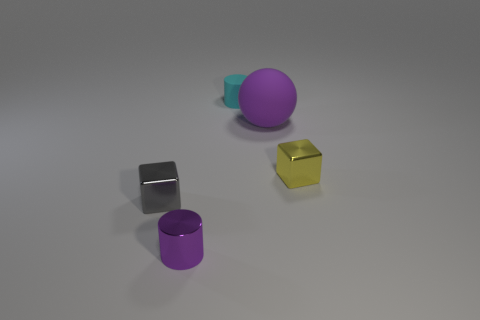There is a yellow thing that is the same shape as the gray metal thing; what is its size?
Your answer should be compact. Small. The small rubber thing that is the same shape as the purple shiny thing is what color?
Offer a terse response. Cyan. What number of objects are either small cubes that are on the right side of the tiny purple cylinder or small objects that are behind the tiny metallic cylinder?
Offer a very short reply. 3. What is the color of the sphere?
Ensure brevity in your answer.  Purple. What number of tiny gray objects have the same material as the cyan object?
Your answer should be compact. 0. Is the number of cyan things greater than the number of tiny metallic objects?
Provide a succinct answer. No. There is a thing on the right side of the purple matte ball; how many rubber balls are on the right side of it?
Give a very brief answer. 0. What number of things are objects to the left of the cyan thing or large yellow things?
Your answer should be compact. 2. Is there a tiny gray shiny thing of the same shape as the tiny matte object?
Make the answer very short. No. What is the shape of the metallic thing that is to the right of the tiny object in front of the gray metallic cube?
Give a very brief answer. Cube. 